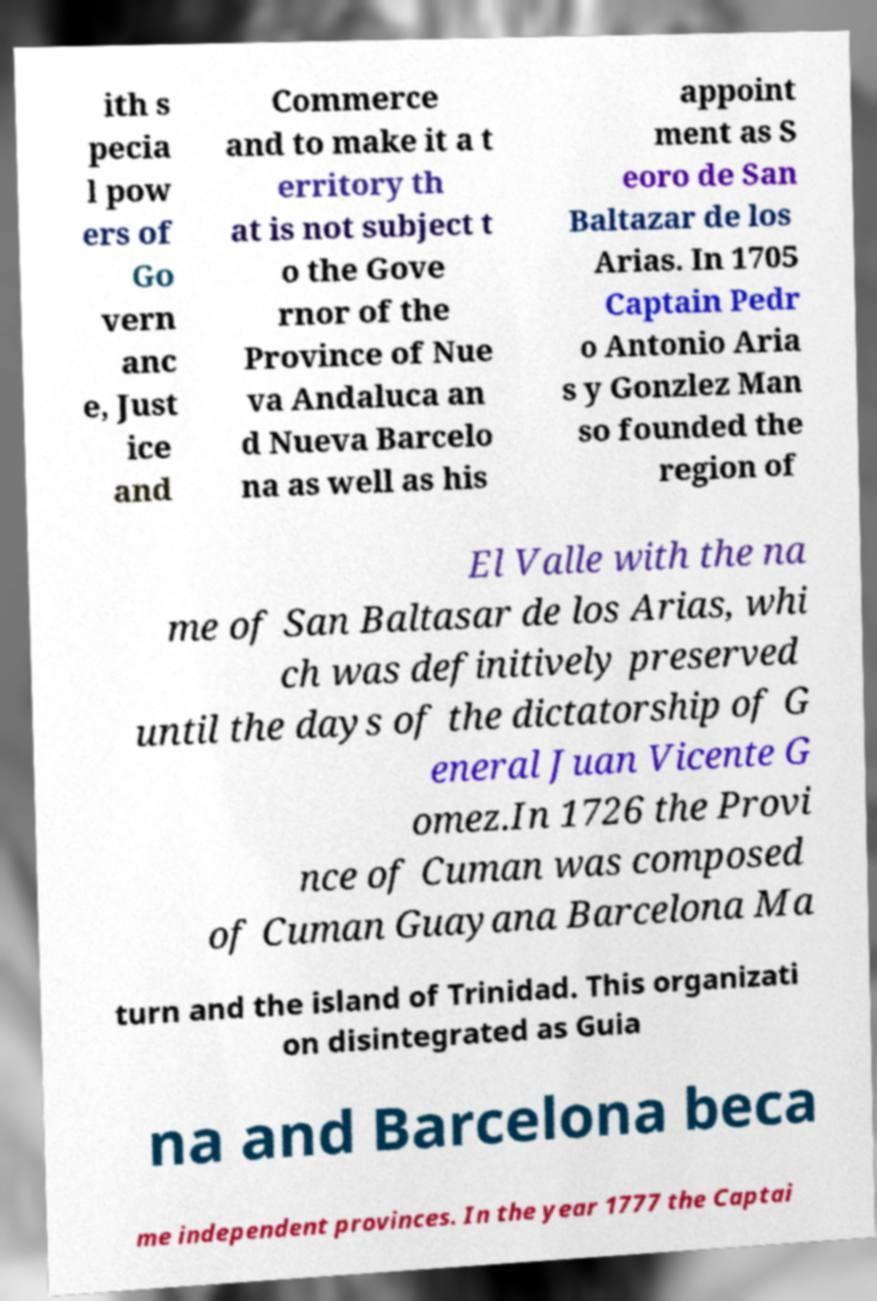Could you extract and type out the text from this image? ith s pecia l pow ers of Go vern anc e, Just ice and Commerce and to make it a t erritory th at is not subject t o the Gove rnor of the Province of Nue va Andaluca an d Nueva Barcelo na as well as his appoint ment as S eoro de San Baltazar de los Arias. In 1705 Captain Pedr o Antonio Aria s y Gonzlez Man so founded the region of El Valle with the na me of San Baltasar de los Arias, whi ch was definitively preserved until the days of the dictatorship of G eneral Juan Vicente G omez.In 1726 the Provi nce of Cuman was composed of Cuman Guayana Barcelona Ma turn and the island of Trinidad. This organizati on disintegrated as Guia na and Barcelona beca me independent provinces. In the year 1777 the Captai 